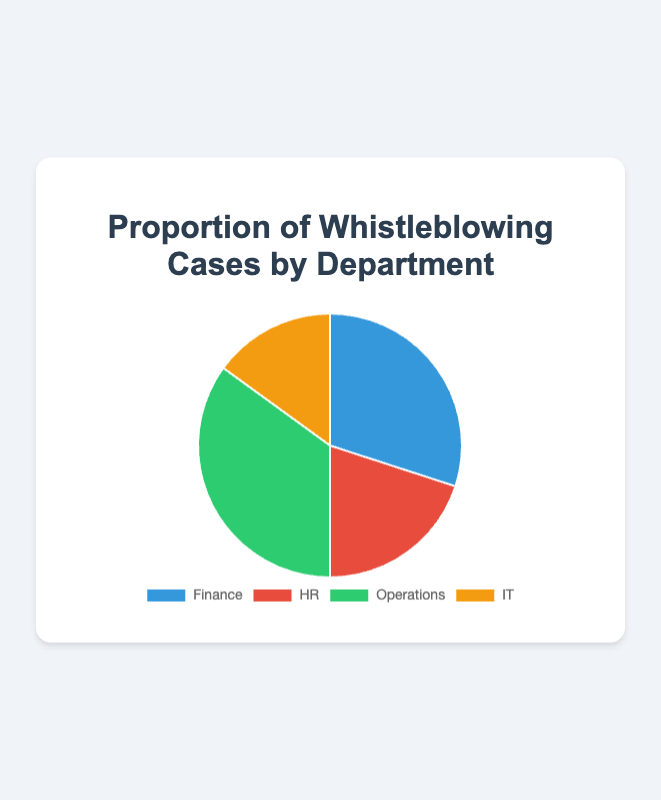What proportion of whistleblowing cases come from the Finance department? The pie chart shows that the Finance department accounts for 30% of the total whistleblowing cases.
Answer: 30% Which department has the highest proportion of whistleblowing cases? By visually comparing the sizes of the pie slices, the Operations department has the largest slice, indicating it has the highest proportion of whistleblowing cases at 35%.
Answer: Operations What is the combined proportion of whistleblowing cases from the HR and IT departments? By summing the proportions for HR (20%) and IT (15%), the combined proportion is 20% + 15% = 35%.
Answer: 35% Which department has the smallest proportion of whistleblowing cases? The smallest slice in the pie chart corresponds to the IT department, which has the smallest proportion at 15%.
Answer: IT Which departments have a higher proportion of whistleblowing cases than the HR department? The HR department has 20% of the cases. Comparing this with the other departments, both Finance (30%) and Operations (35%) have higher proportions.
Answer: Finance, Operations What is the difference in the proportion of whistleblowing cases between Operations and IT? The proportion for Operations is 35% and for IT it is 15%. The difference is 35% - 15% = 20%.
Answer: 20% Rank the departments from the highest to the lowest proportion of whistleblowing cases. By comparing the pie slices, the ranking is: Operations (35%), Finance (30%), HR (20%), IT (15%).
Answer: Operations, Finance, HR, IT What proportion of whistleblowing cases come from departments other than Finance and Operations? The proportions for Finance and Operations are 30% and 35%, respectively. The combined proportion is 30% + 35% = 65%. The proportion for other departments is 100% - 65% = 35% (HR 20% + IT 15%).
Answer: 35% Is the proportion of whistleblowing cases from HR greater than or equal to IT? The HR department has 20% of the cases, while IT has 15%. Since 20% is greater than 15%, the HR department's proportion is greater.
Answer: Greater What's the average proportion of whistleblowing cases among all four departments? To find the average, sum the proportions (30% + 20% + 35% + 15%) and divide by 4. The sum is 100%, so the average is 100% / 4 = 25%.
Answer: 25% 